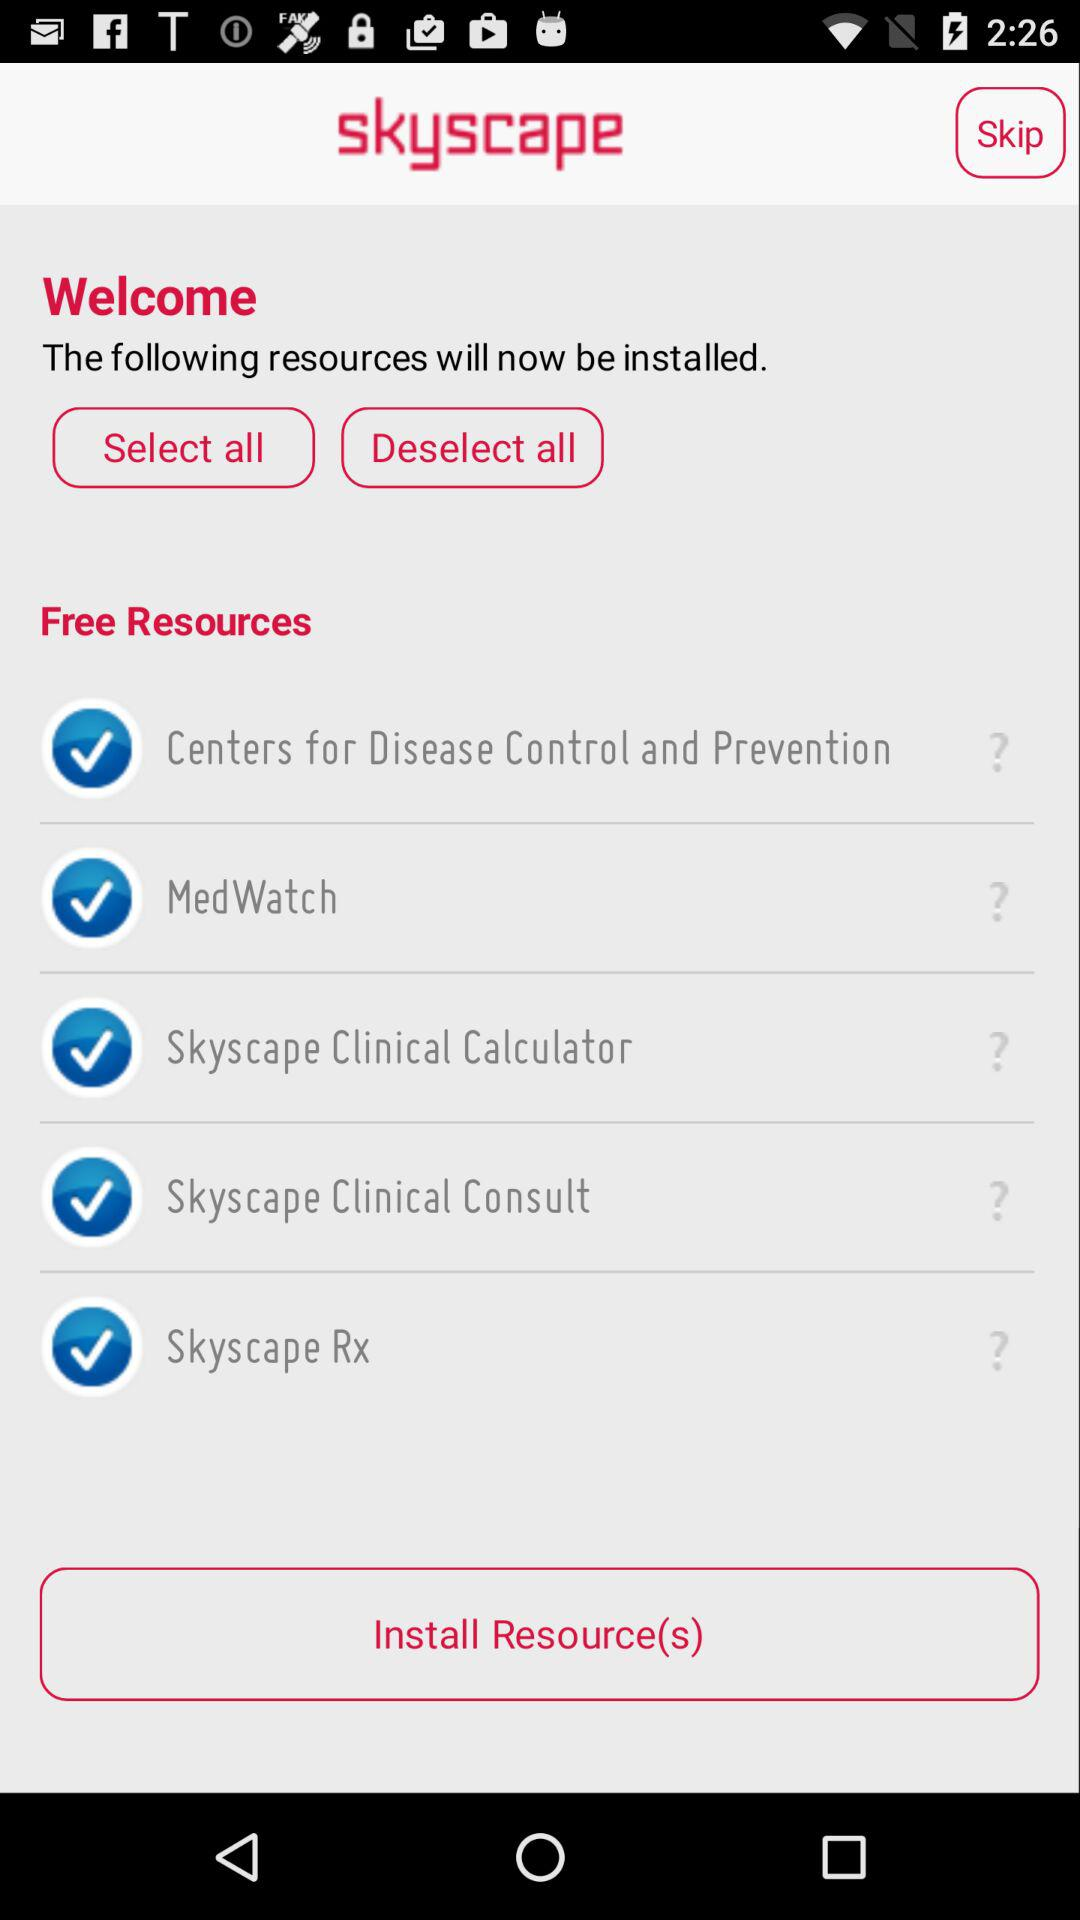How many resources are unchecked?
Answer the question using a single word or phrase. 0 